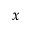Convert formula to latex. <formula><loc_0><loc_0><loc_500><loc_500>x</formula> 